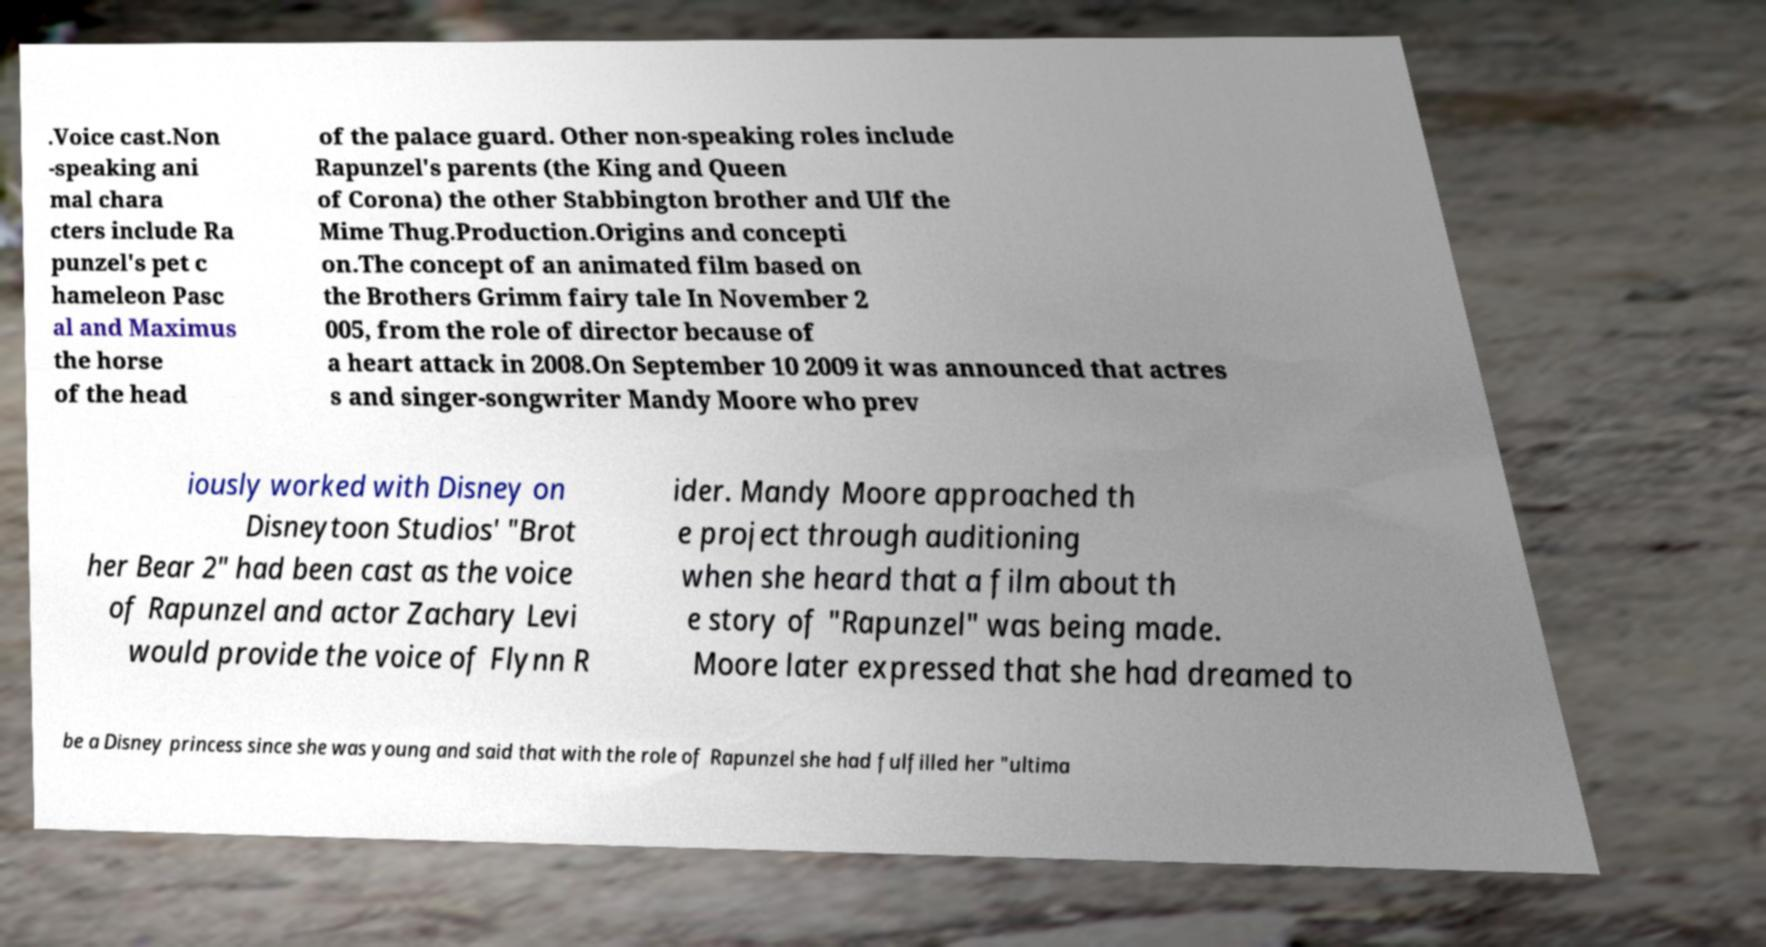What messages or text are displayed in this image? I need them in a readable, typed format. .Voice cast.Non -speaking ani mal chara cters include Ra punzel's pet c hameleon Pasc al and Maximus the horse of the head of the palace guard. Other non-speaking roles include Rapunzel's parents (the King and Queen of Corona) the other Stabbington brother and Ulf the Mime Thug.Production.Origins and concepti on.The concept of an animated film based on the Brothers Grimm fairy tale In November 2 005, from the role of director because of a heart attack in 2008.On September 10 2009 it was announced that actres s and singer-songwriter Mandy Moore who prev iously worked with Disney on Disneytoon Studios' "Brot her Bear 2" had been cast as the voice of Rapunzel and actor Zachary Levi would provide the voice of Flynn R ider. Mandy Moore approached th e project through auditioning when she heard that a film about th e story of "Rapunzel" was being made. Moore later expressed that she had dreamed to be a Disney princess since she was young and said that with the role of Rapunzel she had fulfilled her "ultima 